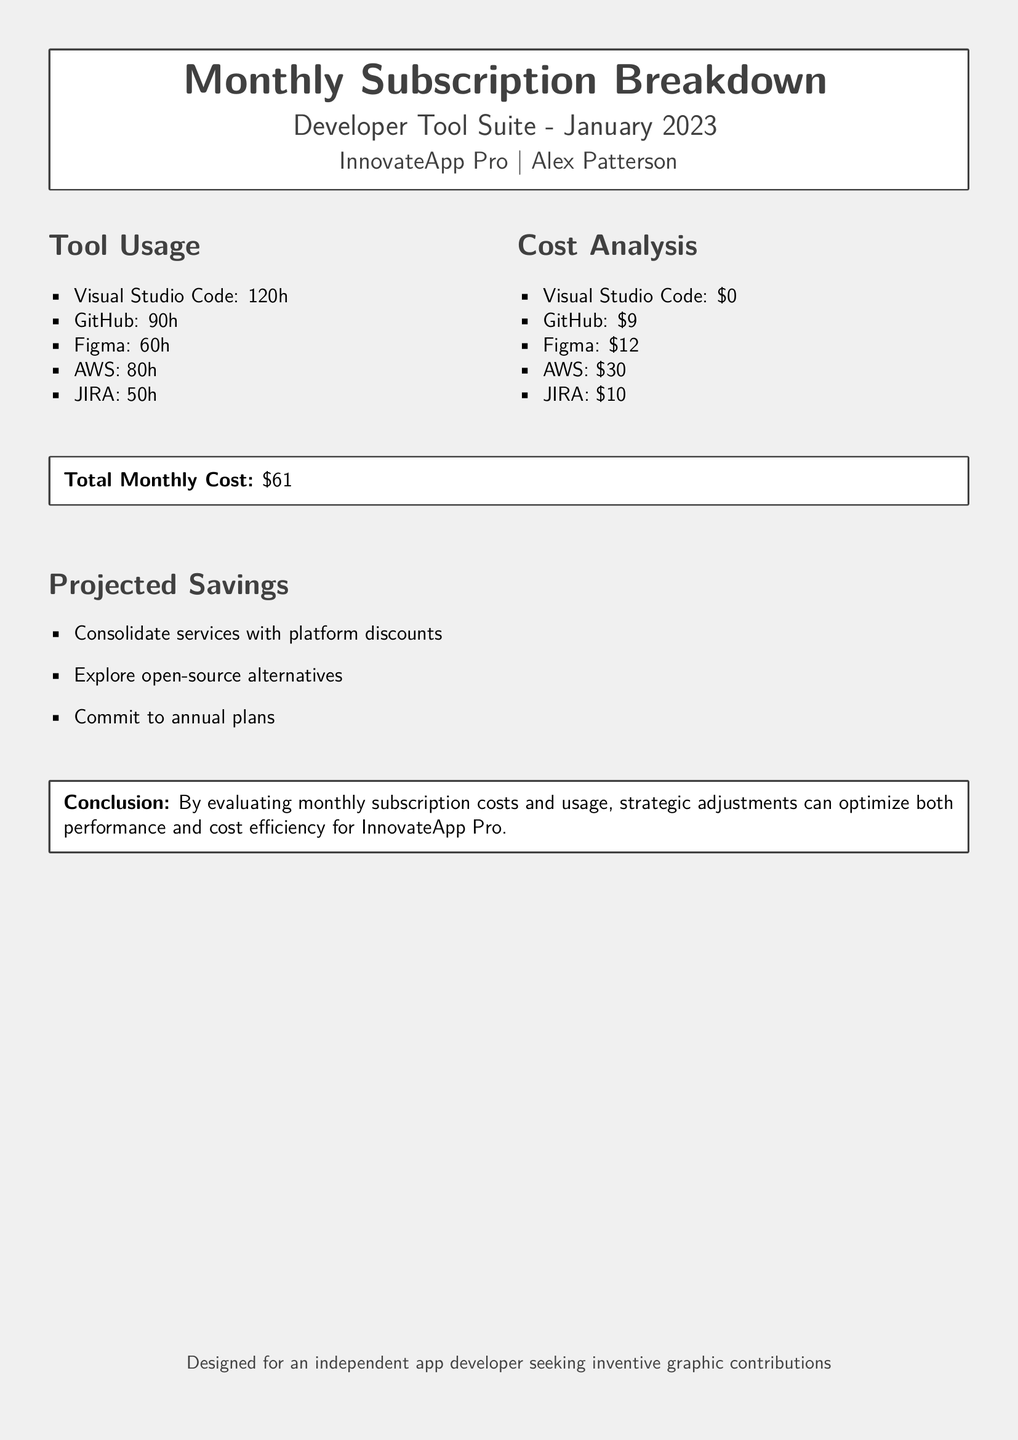What is the title of the document? The title is indicated prominently at the top of the document in bold text.
Answer: Monthly Subscription Breakdown Who is the author of the tool suite? The author is mentioned below the title, providing credit for the content.
Answer: Alex Patterson What is the total monthly cost reported? The total monthly cost is summarized in a box for clarity.
Answer: $61 How many hours were spent on GitHub? The hours spent on GitHub are listed in the tool usage section.
Answer: 90h What is one suggested way to achieve projected savings? The projected savings section outlines methods for potential cost reduction.
Answer: Explore open-source alternatives How many hours were recorded for Figma usage? The exact hours for Figma are detailed in the tool usage list.
Answer: 60h What is the cost associated with AWS? The cost details for AWS are specified in the cost analysis section.
Answer: $30 What is the purpose of this document for readers? The document is designed for a specific audience, outlined at the end.
Answer: Seeking inventive graphic contributions What color is used for the document’s background? The background color is defined at the beginning and influences the document's aesthetic.
Answer: Light gray 